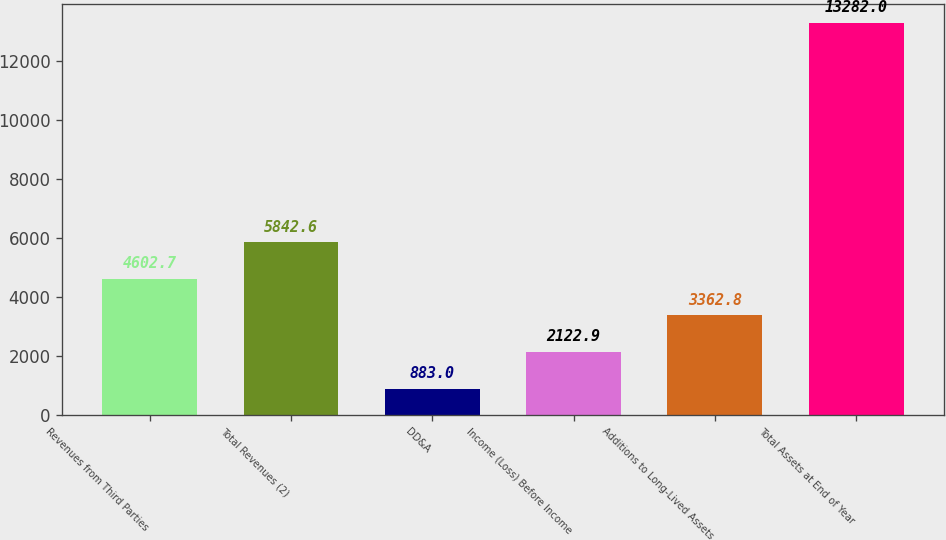Convert chart. <chart><loc_0><loc_0><loc_500><loc_500><bar_chart><fcel>Revenues from Third Parties<fcel>Total Revenues (2)<fcel>DD&A<fcel>Income (Loss) Before Income<fcel>Additions to Long-Lived Assets<fcel>Total Assets at End of Year<nl><fcel>4602.7<fcel>5842.6<fcel>883<fcel>2122.9<fcel>3362.8<fcel>13282<nl></chart> 